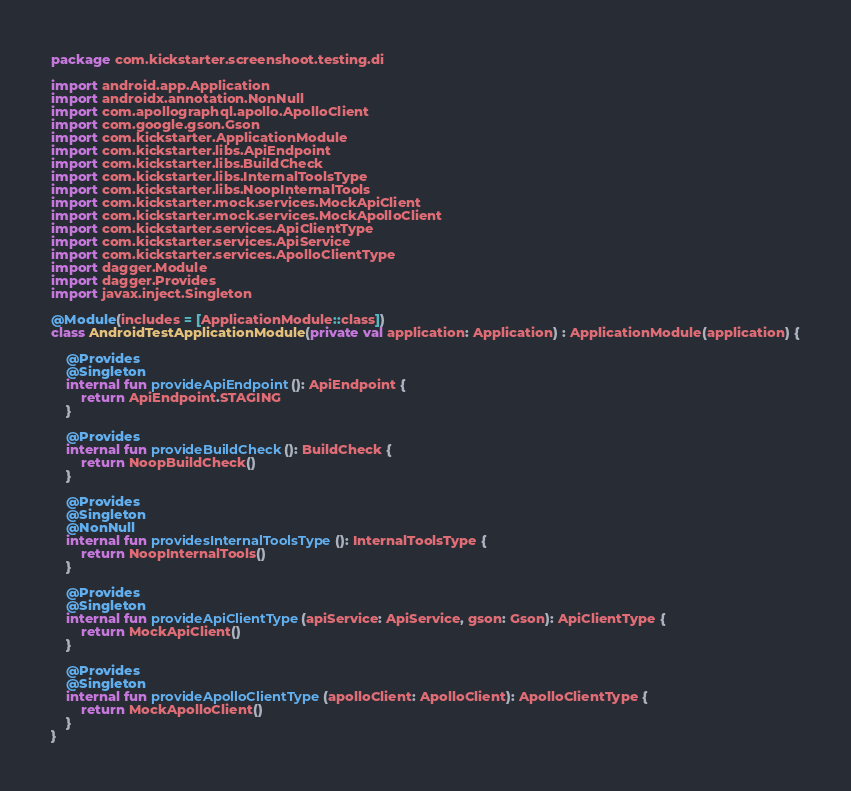Convert code to text. <code><loc_0><loc_0><loc_500><loc_500><_Kotlin_>package com.kickstarter.screenshoot.testing.di

import android.app.Application
import androidx.annotation.NonNull
import com.apollographql.apollo.ApolloClient
import com.google.gson.Gson
import com.kickstarter.ApplicationModule
import com.kickstarter.libs.ApiEndpoint
import com.kickstarter.libs.BuildCheck
import com.kickstarter.libs.InternalToolsType
import com.kickstarter.libs.NoopInternalTools
import com.kickstarter.mock.services.MockApiClient
import com.kickstarter.mock.services.MockApolloClient
import com.kickstarter.services.ApiClientType
import com.kickstarter.services.ApiService
import com.kickstarter.services.ApolloClientType
import dagger.Module
import dagger.Provides
import javax.inject.Singleton

@Module(includes = [ApplicationModule::class])
class AndroidTestApplicationModule(private val application: Application) : ApplicationModule(application) {

    @Provides
    @Singleton
    internal fun provideApiEndpoint(): ApiEndpoint {
        return ApiEndpoint.STAGING
    }

    @Provides
    internal fun provideBuildCheck(): BuildCheck {
        return NoopBuildCheck()
    }

    @Provides
    @Singleton
    @NonNull
    internal fun providesInternalToolsType(): InternalToolsType {
        return NoopInternalTools()
    }

    @Provides
    @Singleton
    internal fun provideApiClientType(apiService: ApiService, gson: Gson): ApiClientType {
        return MockApiClient()
    }

    @Provides
    @Singleton
    internal fun provideApolloClientType(apolloClient: ApolloClient): ApolloClientType {
        return MockApolloClient()
    }
}
</code> 